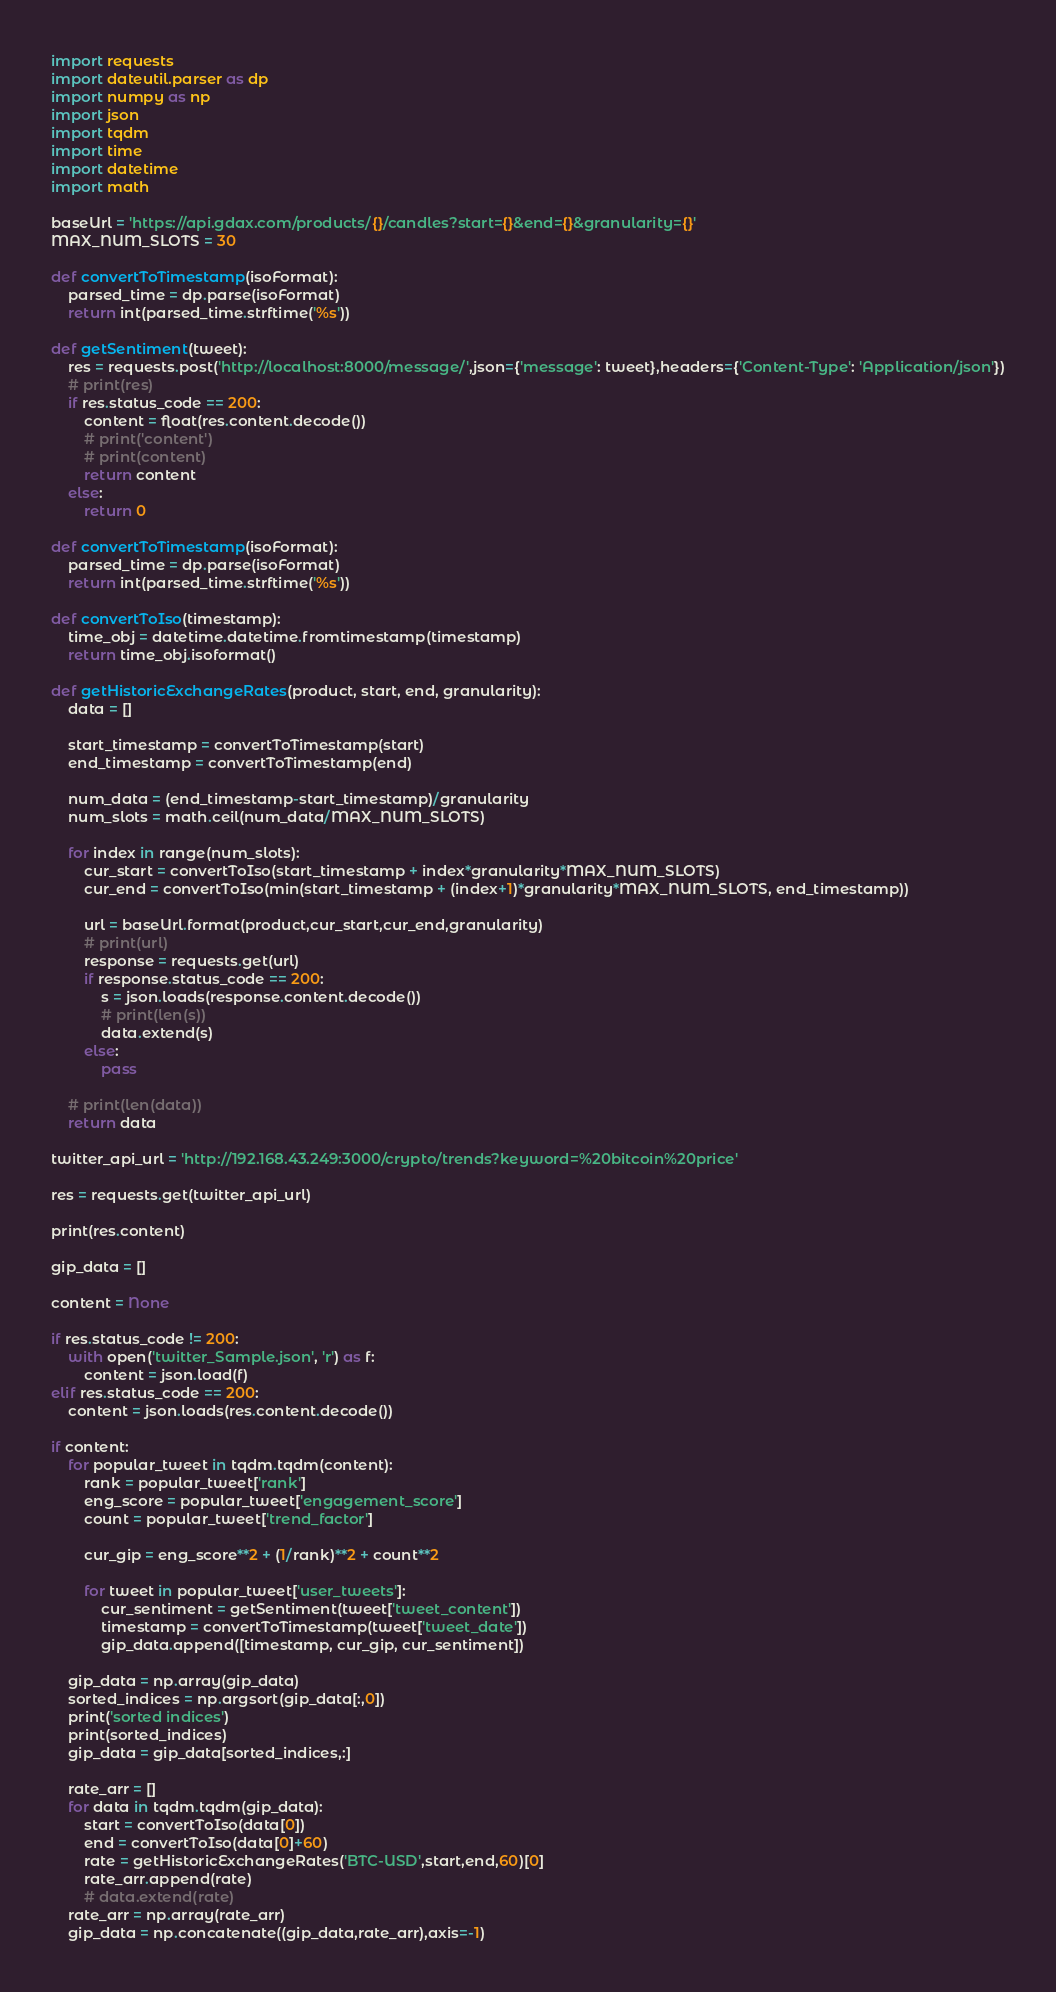Convert code to text. <code><loc_0><loc_0><loc_500><loc_500><_Python_>import requests
import dateutil.parser as dp
import numpy as np
import json
import tqdm
import time
import datetime
import math

baseUrl = 'https://api.gdax.com/products/{}/candles?start={}&end={}&granularity={}'
MAX_NUM_SLOTS = 30

def convertToTimestamp(isoFormat):
	parsed_time = dp.parse(isoFormat)
	return int(parsed_time.strftime('%s'))

def getSentiment(tweet):
	res = requests.post('http://localhost:8000/message/',json={'message': tweet},headers={'Content-Type': 'Application/json'})
	# print(res)
	if res.status_code == 200:
		content = float(res.content.decode())
		# print('content')
		# print(content)
		return content
	else:
		return 0

def convertToTimestamp(isoFormat):
	parsed_time = dp.parse(isoFormat)
	return int(parsed_time.strftime('%s'))

def convertToIso(timestamp):
	time_obj = datetime.datetime.fromtimestamp(timestamp)
	return time_obj.isoformat()

def getHistoricExchangeRates(product, start, end, granularity):
	data = []

	start_timestamp = convertToTimestamp(start)
	end_timestamp = convertToTimestamp(end)

	num_data = (end_timestamp-start_timestamp)/granularity
	num_slots = math.ceil(num_data/MAX_NUM_SLOTS)

	for index in range(num_slots):
		cur_start = convertToIso(start_timestamp + index*granularity*MAX_NUM_SLOTS)
		cur_end = convertToIso(min(start_timestamp + (index+1)*granularity*MAX_NUM_SLOTS, end_timestamp))
		
		url = baseUrl.format(product,cur_start,cur_end,granularity)
		# print(url)
		response = requests.get(url)
		if response.status_code == 200:
			s = json.loads(response.content.decode())
			# print(len(s))
			data.extend(s)
		else:
			pass

	# print(len(data))
	return data

twitter_api_url = 'http://192.168.43.249:3000/crypto/trends?keyword=%20bitcoin%20price'

res = requests.get(twitter_api_url)

print(res.content)

gip_data = []

content = None

if res.status_code != 200:
	with open('twitter_Sample.json', 'r') as f:
		content = json.load(f)
elif res.status_code == 200:
	content = json.loads(res.content.decode())

if content:
	for popular_tweet in tqdm.tqdm(content):
		rank = popular_tweet['rank']
		eng_score = popular_tweet['engagement_score']
		count = popular_tweet['trend_factor']

		cur_gip = eng_score**2 + (1/rank)**2 + count**2

		for tweet in popular_tweet['user_tweets']:
			cur_sentiment = getSentiment(tweet['tweet_content'])
			timestamp = convertToTimestamp(tweet['tweet_date'])
			gip_data.append([timestamp, cur_gip, cur_sentiment])

	gip_data = np.array(gip_data)
	sorted_indices = np.argsort(gip_data[:,0])
	print('sorted indices')
	print(sorted_indices)
	gip_data = gip_data[sorted_indices,:]

	rate_arr = []
	for data in tqdm.tqdm(gip_data):
		start = convertToIso(data[0])
		end = convertToIso(data[0]+60)
		rate = getHistoricExchangeRates('BTC-USD',start,end,60)[0]
		rate_arr.append(rate)
		# data.extend(rate) 
	rate_arr = np.array(rate_arr)
	gip_data = np.concatenate((gip_data,rate_arr),axis=-1)
</code> 